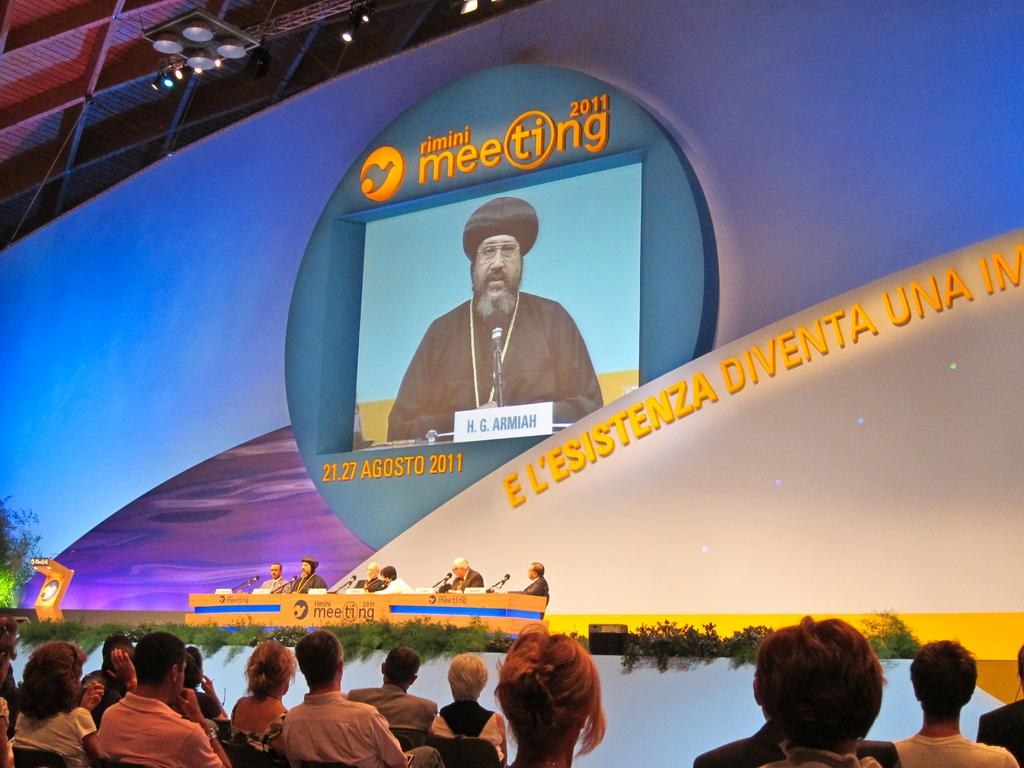<image>
Summarize the visual content of the image. a conference of a Rimini Meeting 2011 from 21.27 Agosto 